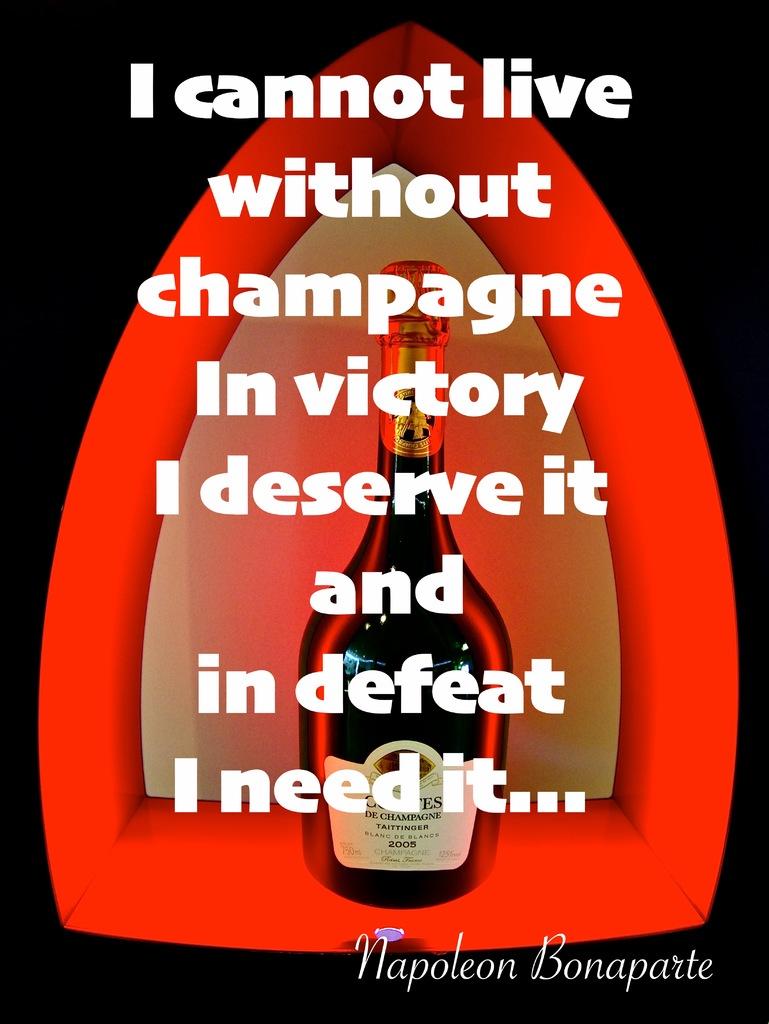What can they not live without?
Provide a succinct answer. Champagne. Who said this quote?
Provide a succinct answer. Napoleon bonaparte. 